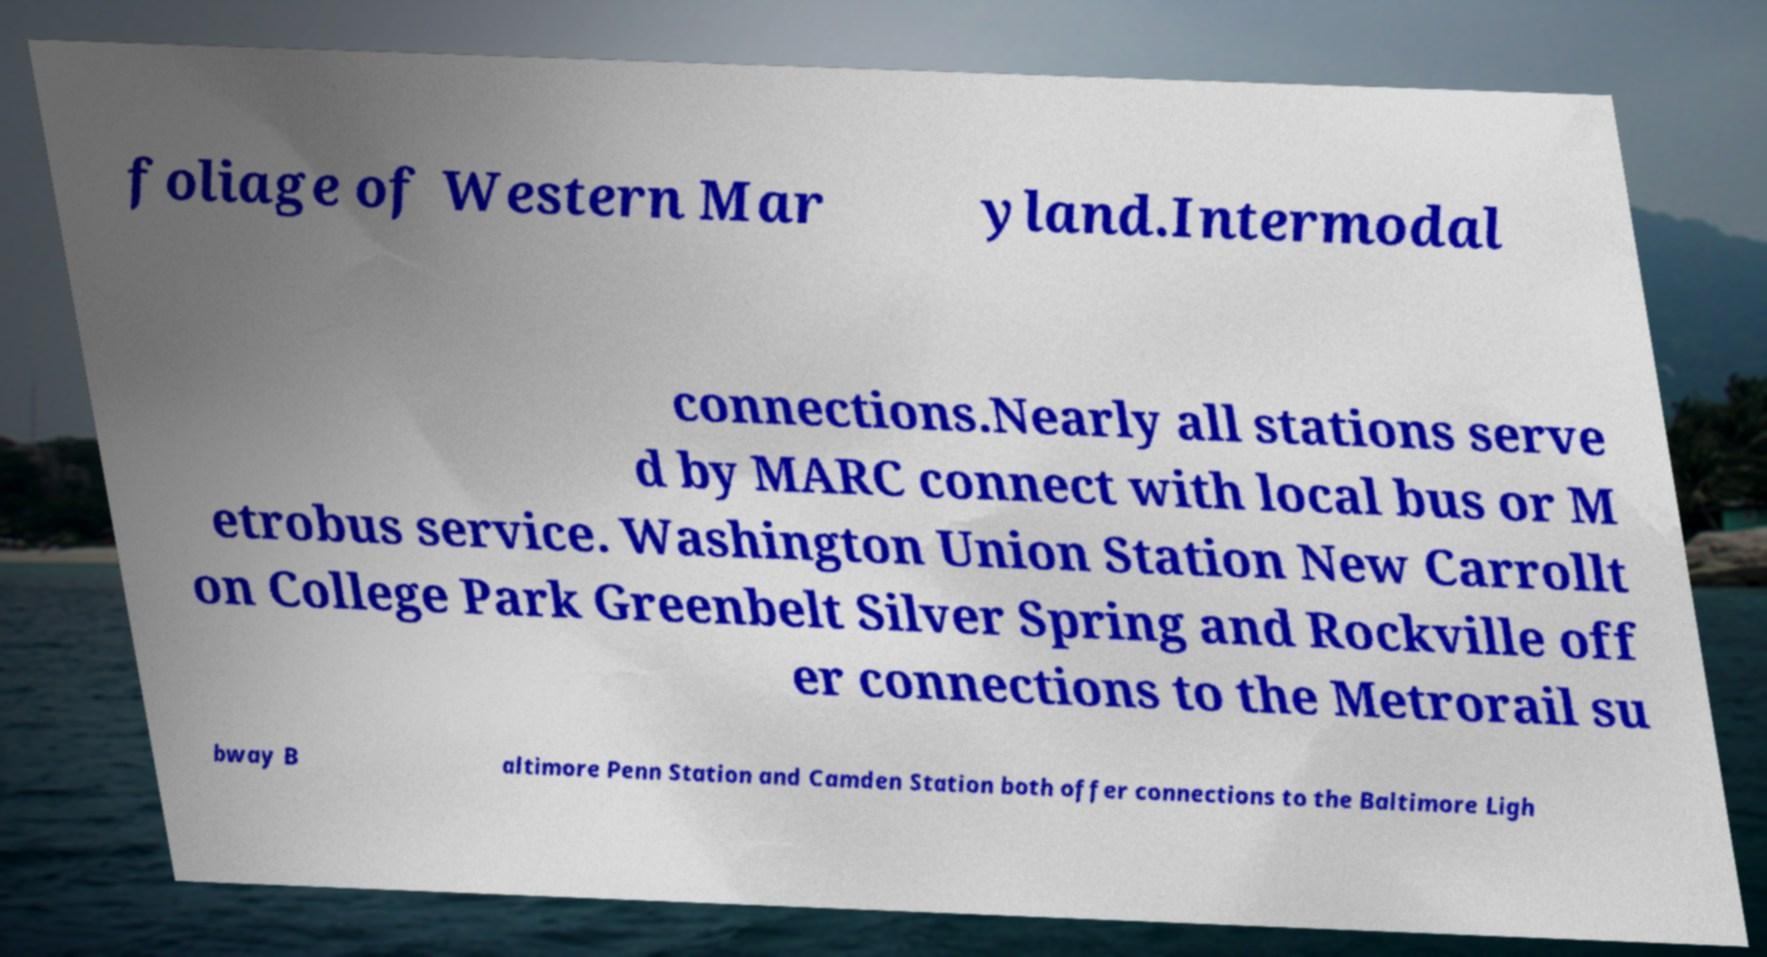Please read and relay the text visible in this image. What does it say? foliage of Western Mar yland.Intermodal connections.Nearly all stations serve d by MARC connect with local bus or M etrobus service. Washington Union Station New Carrollt on College Park Greenbelt Silver Spring and Rockville off er connections to the Metrorail su bway B altimore Penn Station and Camden Station both offer connections to the Baltimore Ligh 